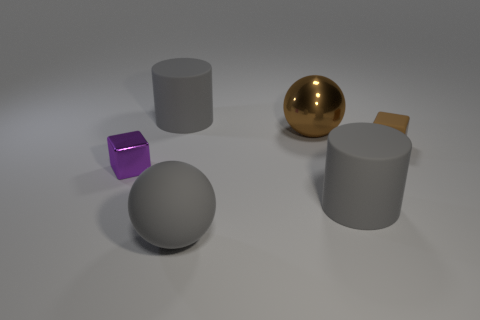Add 4 large yellow rubber cubes. How many objects exist? 10 Subtract all brown metal spheres. Subtract all rubber spheres. How many objects are left? 4 Add 2 small metallic cubes. How many small metallic cubes are left? 3 Add 6 matte spheres. How many matte spheres exist? 7 Subtract 0 cyan cylinders. How many objects are left? 6 